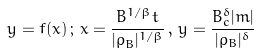Convert formula to latex. <formula><loc_0><loc_0><loc_500><loc_500>y = f ( x ) \, ; \, x = \frac { B ^ { 1 / \beta } t } { | \rho _ { B } | ^ { 1 / \beta } } \, , \, y = \frac { B _ { c } ^ { \delta } | m | } { | \rho _ { B } | ^ { \delta } }</formula> 